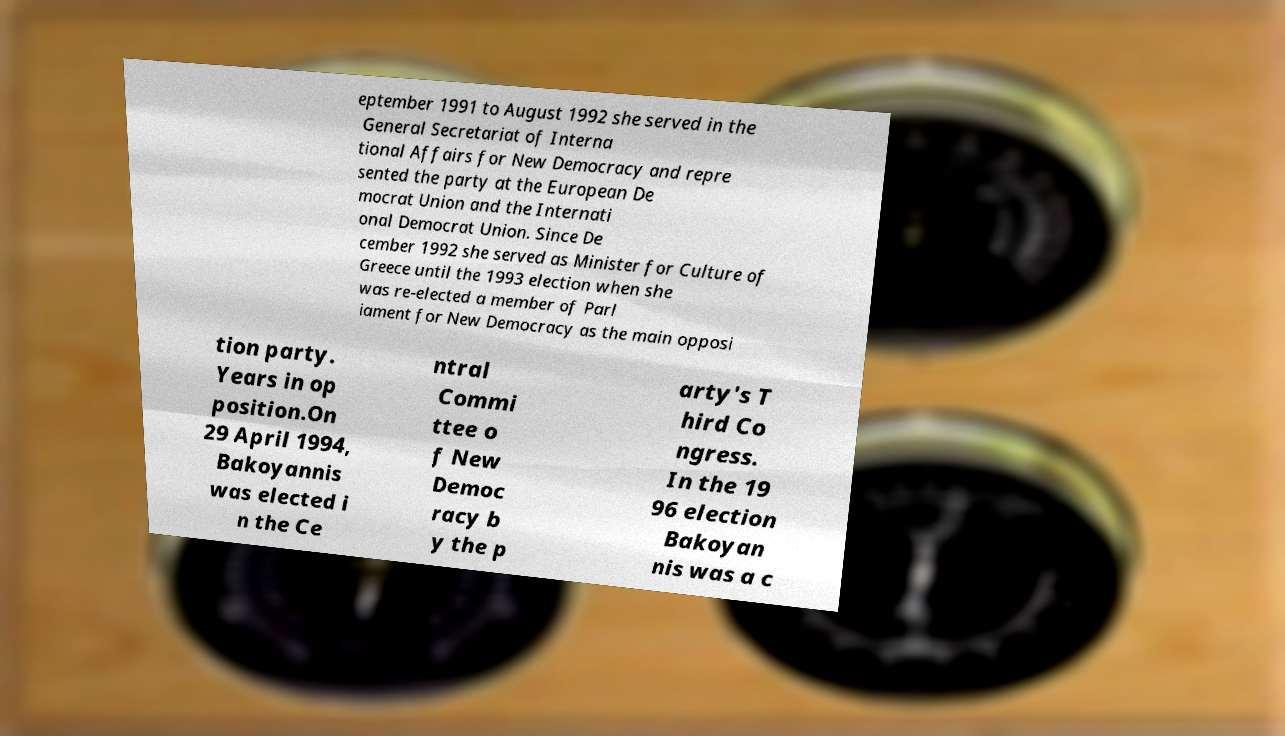I need the written content from this picture converted into text. Can you do that? eptember 1991 to August 1992 she served in the General Secretariat of Interna tional Affairs for New Democracy and repre sented the party at the European De mocrat Union and the Internati onal Democrat Union. Since De cember 1992 she served as Minister for Culture of Greece until the 1993 election when she was re-elected a member of Parl iament for New Democracy as the main opposi tion party. Years in op position.On 29 April 1994, Bakoyannis was elected i n the Ce ntral Commi ttee o f New Democ racy b y the p arty's T hird Co ngress. In the 19 96 election Bakoyan nis was a c 